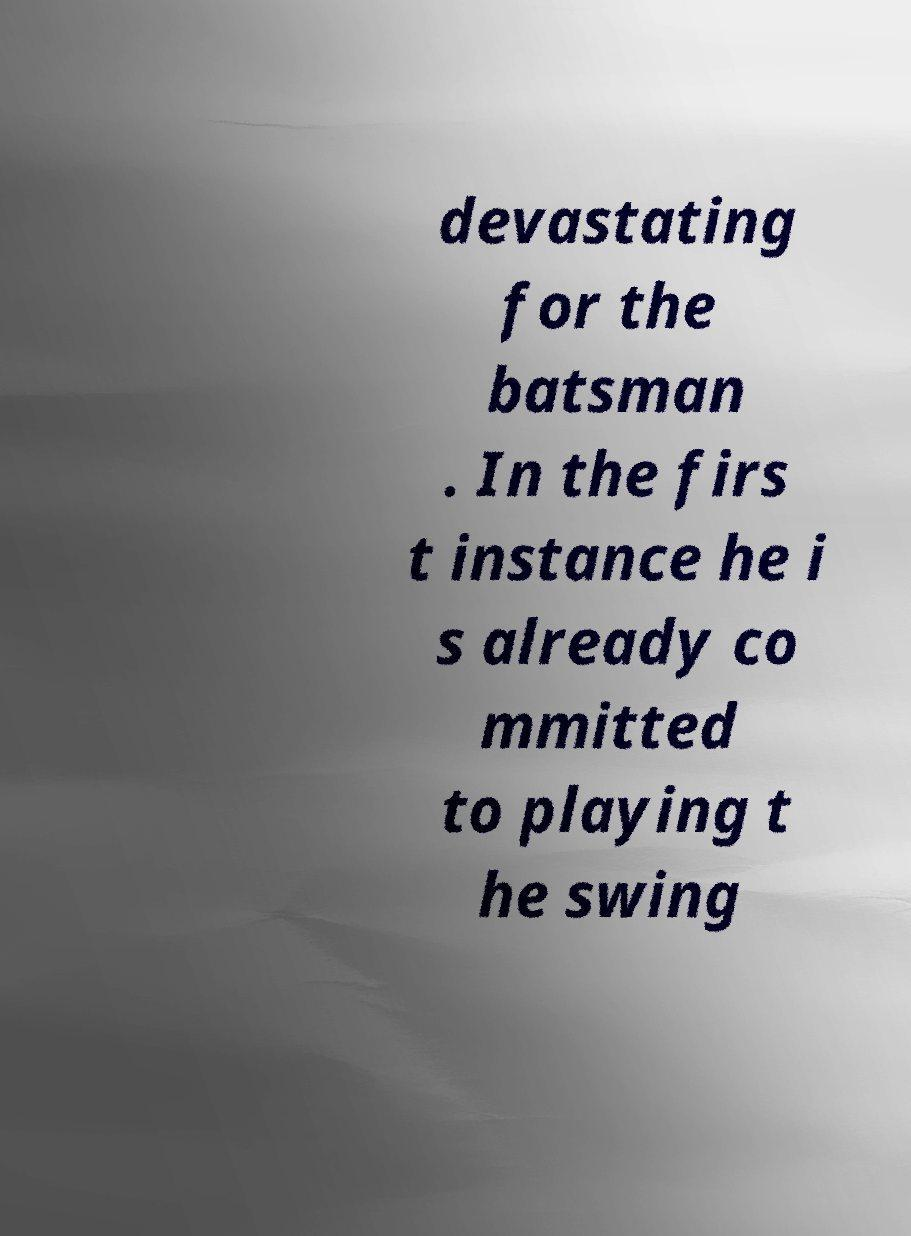Can you accurately transcribe the text from the provided image for me? devastating for the batsman . In the firs t instance he i s already co mmitted to playing t he swing 